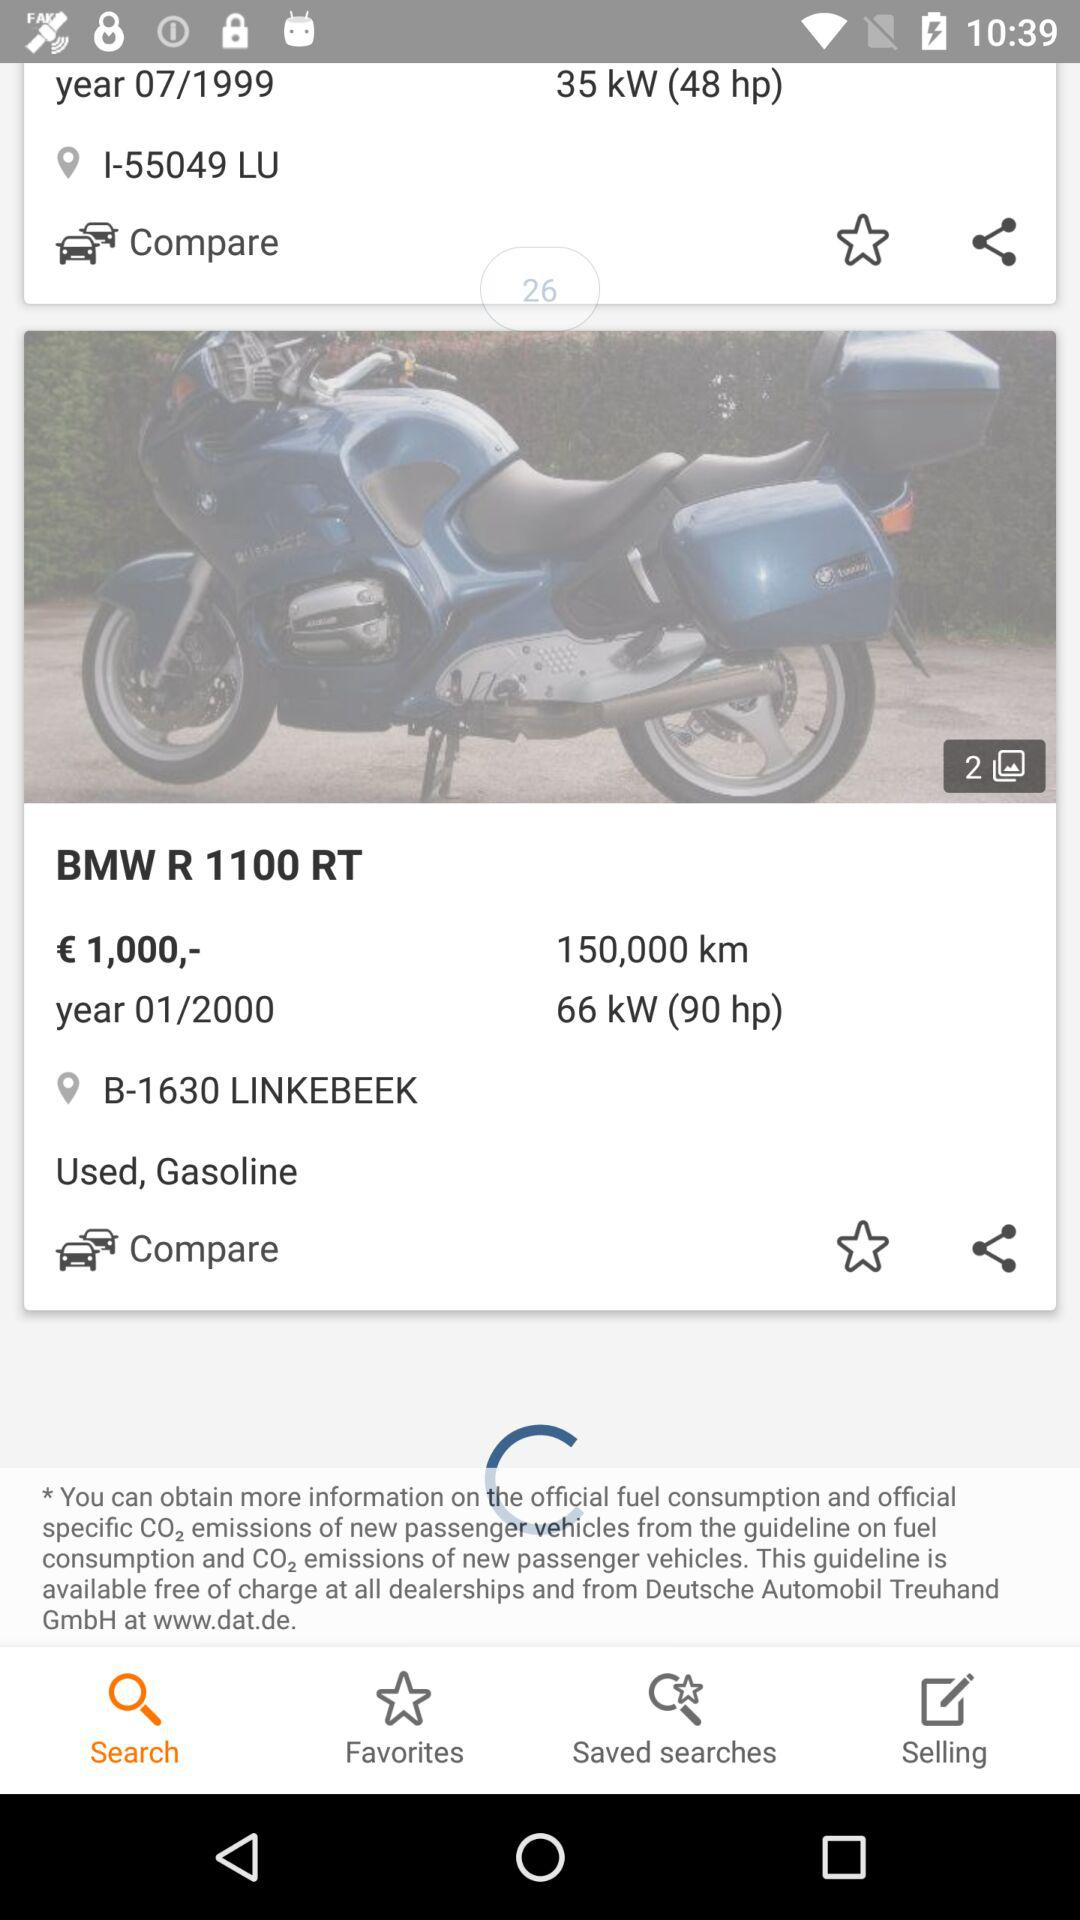What is the price of the BMW R 1100 RT?
Answer the question using a single word or phrase. € 1,000,- 